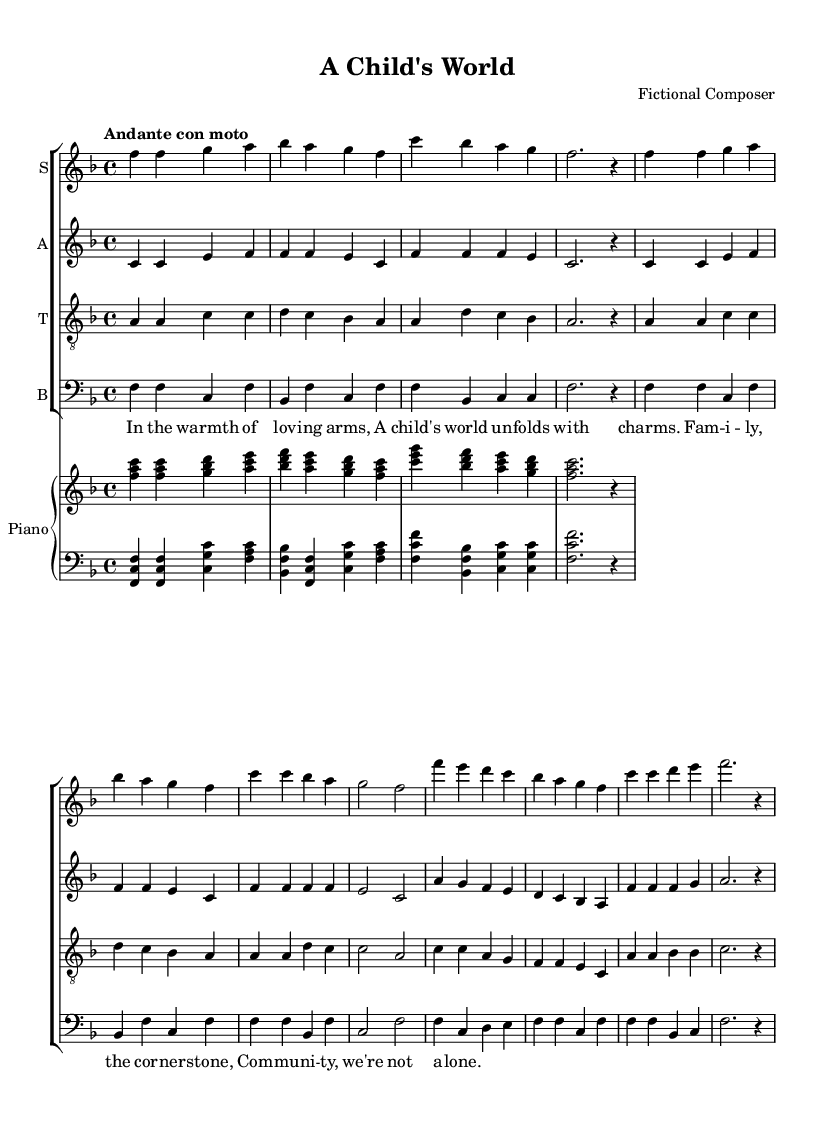What is the key signature of this music? The key signature is F major, which has one flat (B flat). This can be determined by examining the key signature section found at the beginning of the score.
Answer: F major What is the time signature of this piece? The time signature is 4/4, indicating four beats per measure and a quarter note gets one beat. This information is typically located at the beginning of the score in the relevant section.
Answer: 4/4 What is the tempo marking for this composition? The tempo marking is "Andante con moto," suggesting a moderately slow tempo with some movement. The tempo can be identified in the tempo indication near the beginning of the score.
Answer: Andante con moto Which voices are included in this choral work? The voices included are soprano, alto, tenor, and bass. This information can be found in the staff labels and the context of the score showing the four-part choral arrangement.
Answer: Soprano, alto, tenor, bass How many measures are there in each voice part? Each voice part has eight measures. This is determined by counting the individual measure bars for each voice line, which are consistently organized.
Answer: Eight What is the central theme conveyed in the lyrics? The central theme conveyed is the importance of family and community. This is illustrated by the lyrics themselves, which celebrate familial bonds and support among communities.
Answer: Family and community What is the primary emotion evoked through the music and lyrics? The primary emotion evoked is warmth and love. This can be inferred from the lyrical content and melodic lines, which aim to create a cozy and nurturing atmosphere.
Answer: Warmth and love 